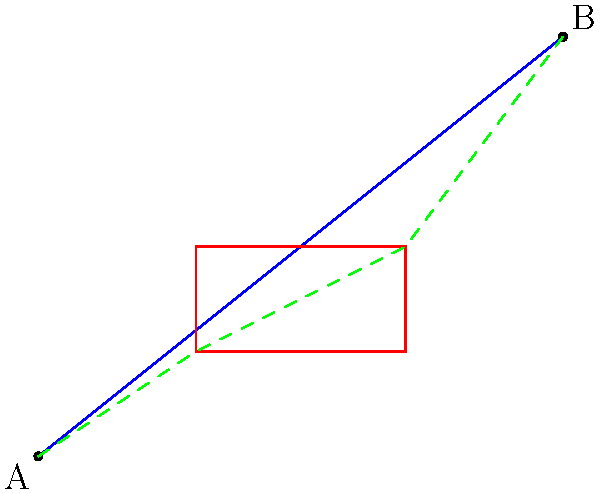In a software localization project, you need to optimize the path of a language selection cursor between two points while avoiding a rectangular obstacle (representing a non-interactive UI element). Given the starting point A(0,0), ending point B(10,8), and a rectangular obstacle with corners at (3,2) and (7,4), what is the length of the shortest path from A to B that avoids the obstacle? To find the shortest path while avoiding the obstacle, we need to follow these steps:

1) The shortest path will consist of straight line segments from A to a corner of the rectangle, and then from that corner to B.

2) There are four possible paths to consider:
   a) A to (3,2) to B
   b) A to (3,4) to B
   c) A to (7,2) to B
   d) A to (7,4) to B

3) We need to calculate the length of each path using the distance formula:
   $d = \sqrt{(x_2-x_1)^2 + (y_2-y_1)^2}$

4) Let's calculate each path:
   a) $\sqrt{3^2 + 2^2} + \sqrt{7^2 + 6^2} = \sqrt{13} + \sqrt{85}$
   b) $\sqrt{3^2 + 4^2} + \sqrt{7^2 + 4^2} = 5 + \sqrt{65}$
   c) $\sqrt{7^2 + 2^2} + \sqrt{3^2 + 6^2} = \sqrt{53} + \sqrt{45}$
   d) $\sqrt{7^2 + 4^2} + \sqrt{3^2 + 4^2} = \sqrt{65} + 5$

5) Comparing these values:
   a) $\approx 12.89$
   b) $\approx 13.06$
   c) $\approx 13.83$
   d) $\approx 13.06$

6) The shortest path is option (a), which goes through the point (3,2).

7) Therefore, the length of the shortest path is $\sqrt{13} + \sqrt{85}$.
Answer: $\sqrt{13} + \sqrt{85}$ 